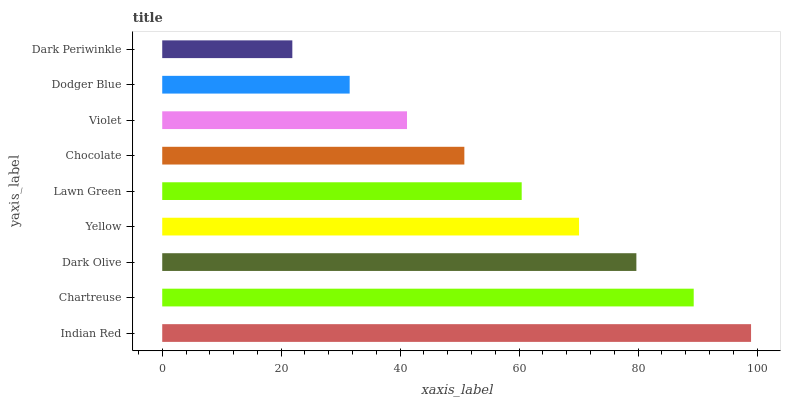Is Dark Periwinkle the minimum?
Answer yes or no. Yes. Is Indian Red the maximum?
Answer yes or no. Yes. Is Chartreuse the minimum?
Answer yes or no. No. Is Chartreuse the maximum?
Answer yes or no. No. Is Indian Red greater than Chartreuse?
Answer yes or no. Yes. Is Chartreuse less than Indian Red?
Answer yes or no. Yes. Is Chartreuse greater than Indian Red?
Answer yes or no. No. Is Indian Red less than Chartreuse?
Answer yes or no. No. Is Lawn Green the high median?
Answer yes or no. Yes. Is Lawn Green the low median?
Answer yes or no. Yes. Is Dark Periwinkle the high median?
Answer yes or no. No. Is Dark Periwinkle the low median?
Answer yes or no. No. 